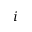Convert formula to latex. <formula><loc_0><loc_0><loc_500><loc_500>i</formula> 